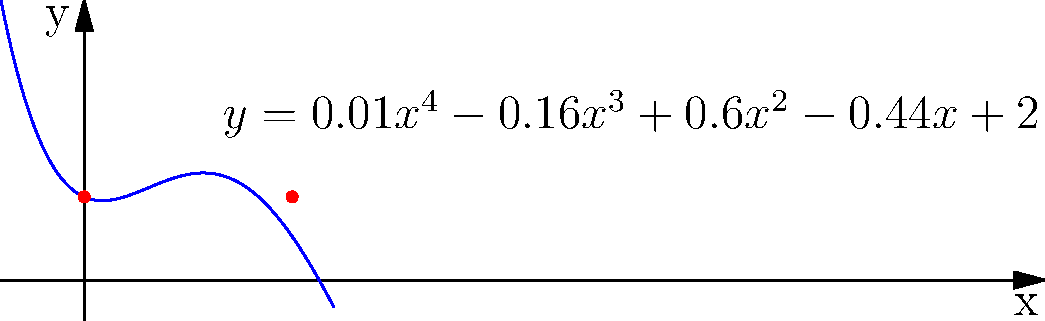As a former competitive swimmer, you're consulting on the design of a new Olympic-sized pool. The cross-section of the pool is represented by the quartic function $y = 0.01x^4 - 0.16x^3 + 0.6x^2 - 0.44x + 2$, where $x$ is the horizontal distance in meters and $y$ is the depth in meters. What is the width of the pool at a depth of 2 meters? To find the width of the pool at a depth of 2 meters, we need to solve the equation:

$2 = 0.01x^4 - 0.16x^3 + 0.6x^2 - 0.44x + 2$

Let's approach this step-by-step:

1) First, subtract 2 from both sides:
   $0 = 0.01x^4 - 0.16x^3 + 0.6x^2 - 0.44x$

2) Factor out x:
   $0 = x(0.01x^3 - 0.16x^2 + 0.6x - 0.44)$

3) One solution is x = 0. For the other solutions, we need to solve:
   $0.01x^3 - 0.16x^2 + 0.6x - 0.44 = 0$

4) This cubic equation can be solved using a graphing calculator or computer algebra system. The solutions are approximately:
   $x ≈ 0, 5$

5) The solution x = 0 corresponds to the left edge of the pool, and x ≈ 5 corresponds to the right edge.

6) The width of the pool at a depth of 2 meters is the distance between these two points.

Therefore, the width of the pool at a depth of 2 meters is approximately 5 meters.
Answer: 5 meters 